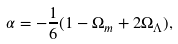<formula> <loc_0><loc_0><loc_500><loc_500>\alpha = - \frac { 1 } { 6 } ( 1 - \Omega _ { m } + 2 \Omega _ { \Lambda } ) ,</formula> 